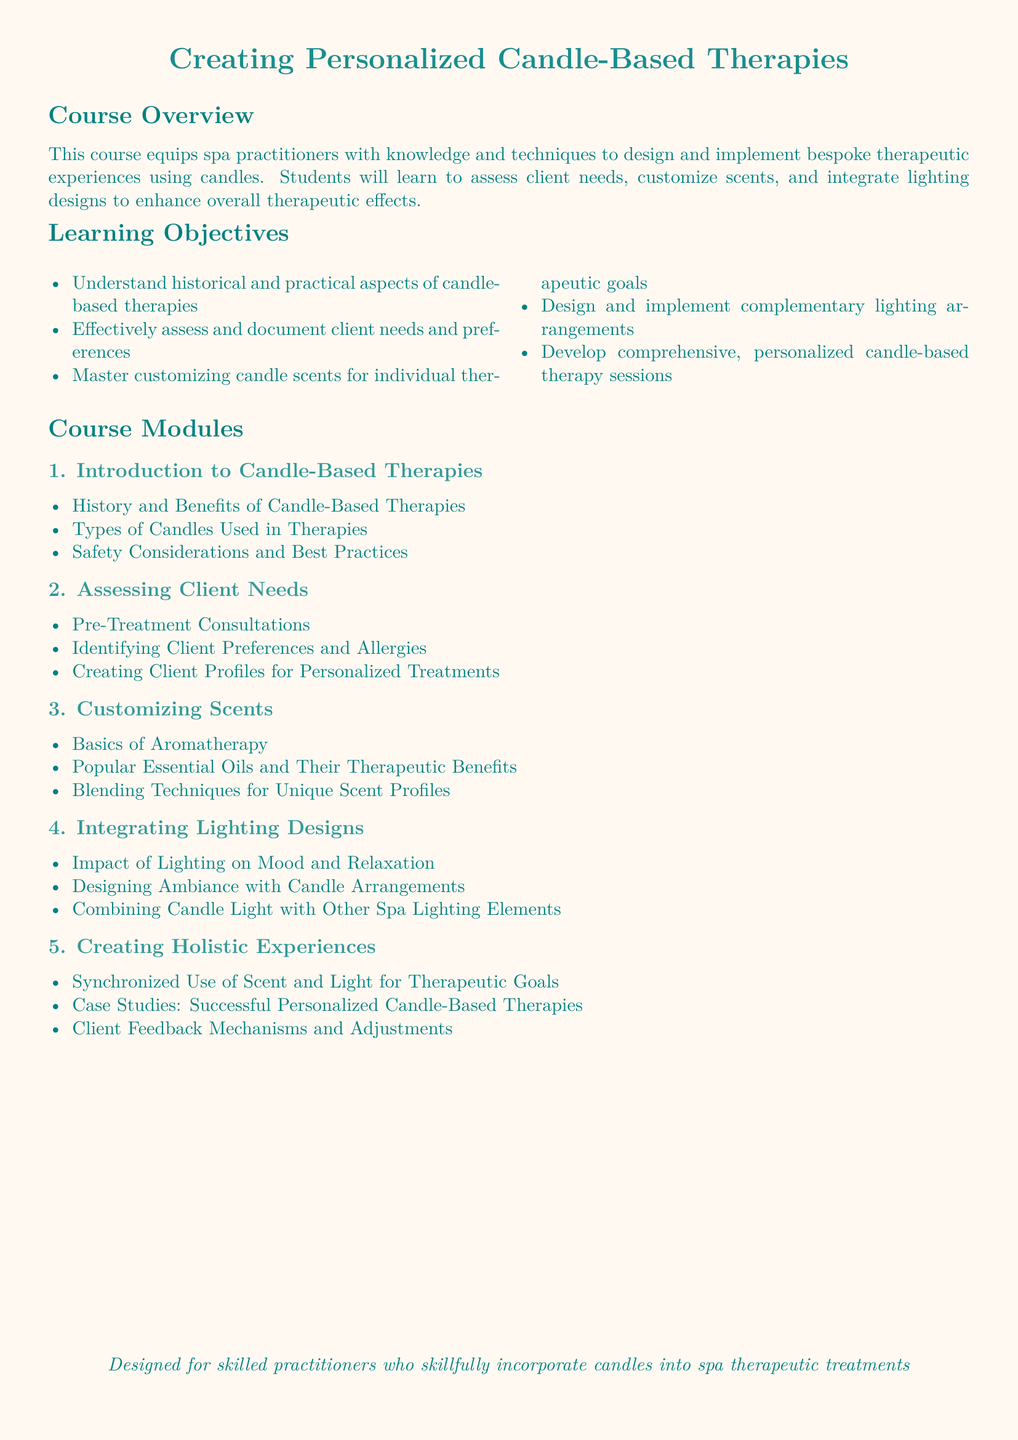What is the title of the course? The title of the course is prominently stated at the beginning of the document.
Answer: Creating Personalized Candle-Based Therapies How many learning objectives are listed? The document outlines a total of five learning objectives, as listed in the 'Learning Objectives' section.
Answer: 5 What is one type of candle used in therapies? The document references various types of candles in the 'Types of Candles Used in Therapies' section without specifying in the questions.
Answer: (any type mentioned in materials) What is the focus of module 3? Module 3 specifically addresses the topic related to scents in the therapy process.
Answer: Customizing Scents What is the importance of pre-treatment consultations? This section highlights the significance of understanding client needs before starting treatments.
Answer: Assessing Client Needs What is the main outcome targeted in the last module? The final module emphasizes creating a comprehensive experience incorporating different sensory elements.
Answer: Holistic Experiences Which essential oil aspect is covered in module 3? The module discusses popular essential oils and their associated benefits within the context of therapy.
Answer: Therapeutic Benefits What does the course aim to integrate with candle therapies? The course aims to connect different sensory elements to enhance therapeutic effects with candle therapies.
Answer: Lighting Designs How are client feedback mechanisms addressed? Client feedback mechanisms are discussed in the context of making adjustments to therapy based on individual experiences.
Answer: Creating Holistic Experiences 